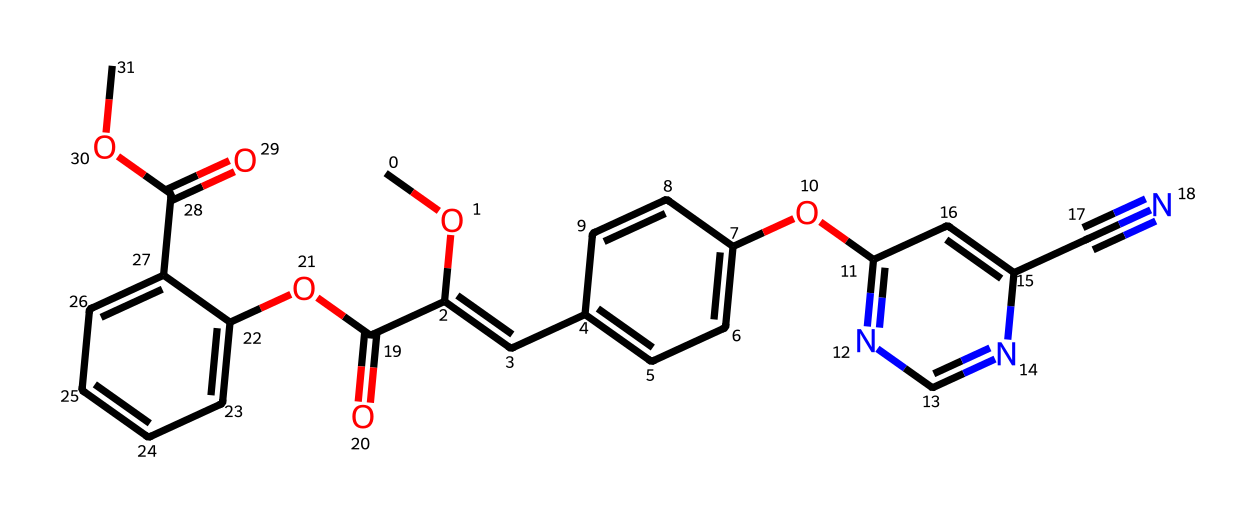What is the molecular formula of azoxystrobin? To determine the molecular formula from the SMILES representation, I count the number of each type of atom present in the structure. The molecular formula of azoxystrobin is calculated as C18H18N4O5.
Answer: C18H18N4O5 How many rings are present in the structure? By analyzing the SMILES representation, I can identify the numbered atoms that indicate cyclic structures. In the given chemical, there are 2 rings formed in the structure.
Answer: 2 What functional groups are present in azoxystrobin? By examining the structure, I can identify the functional groups based on the specific arrangements of atoms. Azoxystrobin contains ester (C(=O)OC) and ether (R-O-R) functional groups.
Answer: ester and ether What is the role of the cyano group in the chemical structure? The cyano group (C#N) typically contributes to the biological activity of the compound by enhancing its stability against degradation, serving as a site for interaction with biological targets.
Answer: stability How does the arrangement of nitrogen atoms affect the photostability of azoxystrobin? The arrangement of nitrogen atoms in azoxystrobin forms two adjacent aromatic systems which stabilize the structure by delocalizing electrons. This helps in maintaining the stability against photodecomposition.
Answer: stabilizing effect What types of bonds are dominant in azoxystrobin? In examining the SMILES structure, I can determine the types of bonds present by looking for single, double, and triple bond indicators. The dominant types of bonds in azoxystrobin are C-C (single) and C=N (double).
Answer: C-C and C=N Which atom is most likely responsible for the chemical's reactivity? From the SMILES representation, the presence of nitrogen indicates a higher reactivity, especially in photoreactive chemicals, as it can take part in various reactions during photolysis.
Answer: nitrogen 